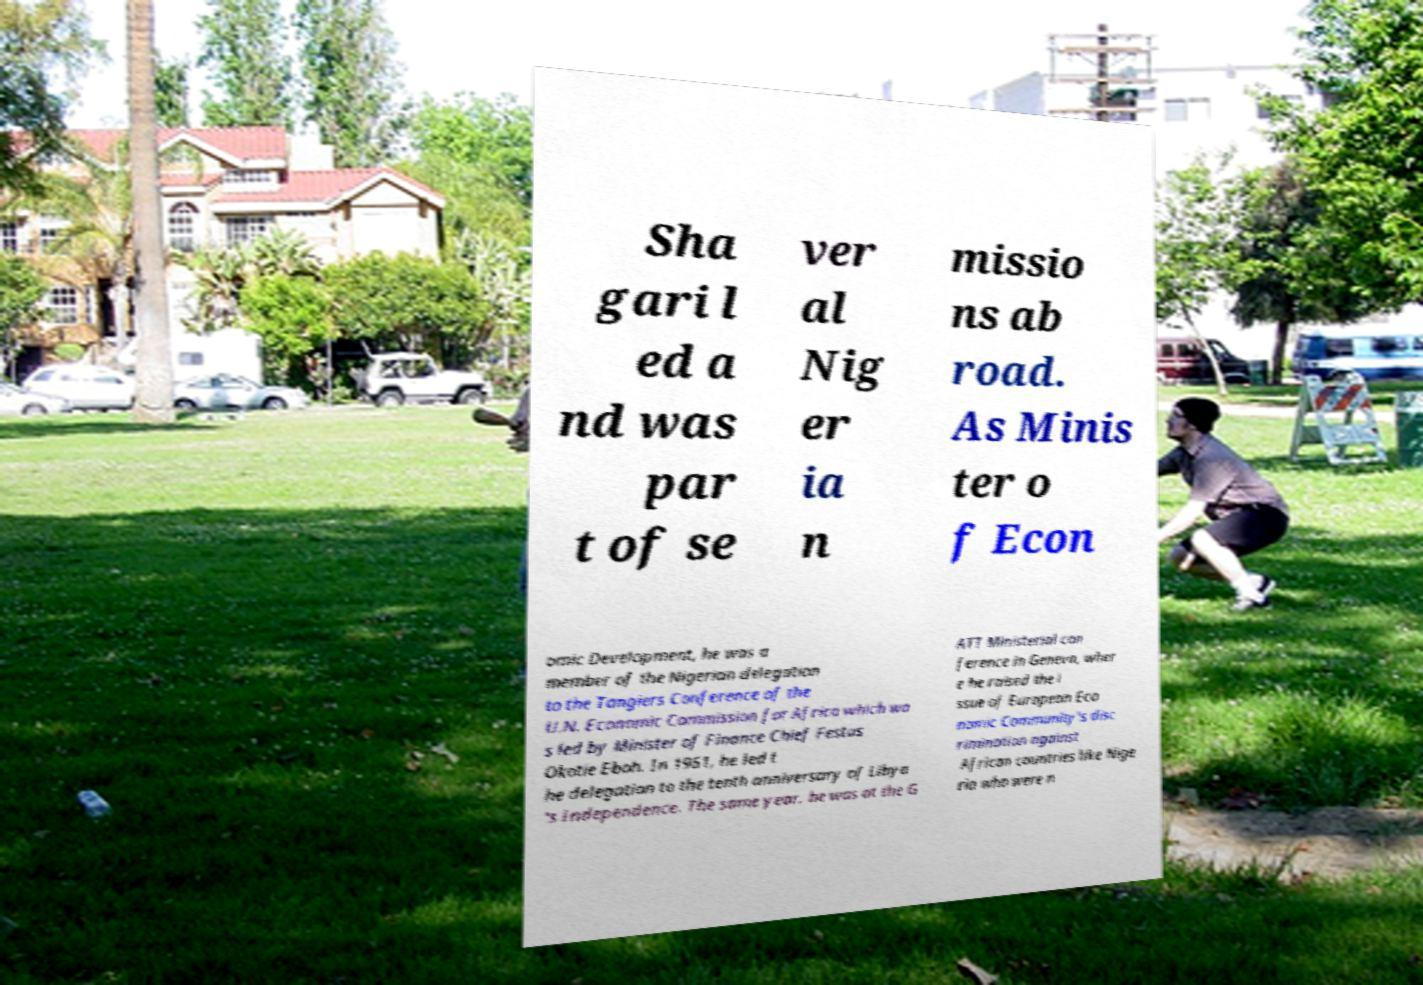Could you extract and type out the text from this image? Sha gari l ed a nd was par t of se ver al Nig er ia n missio ns ab road. As Minis ter o f Econ omic Development, he was a member of the Nigerian delegation to the Tangiers Conference of the U.N. Economic Commission for Africa which wa s led by Minister of Finance Chief Festus Okotie Eboh. In 1961, he led t he delegation to the tenth anniversary of Libya 's Independence. The same year, he was at the G ATT Ministerial con ference in Geneva, wher e he raised the i ssue of European Eco nomic Community's disc rimination against African countries like Nige ria who were n 